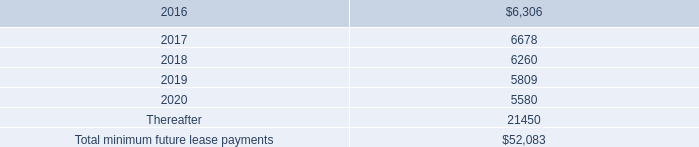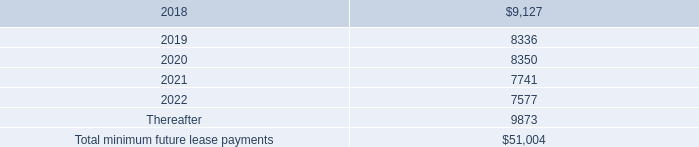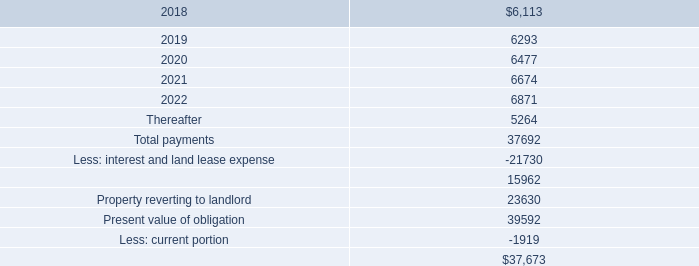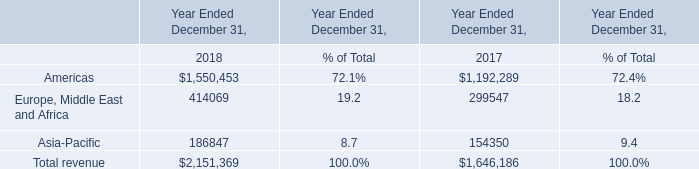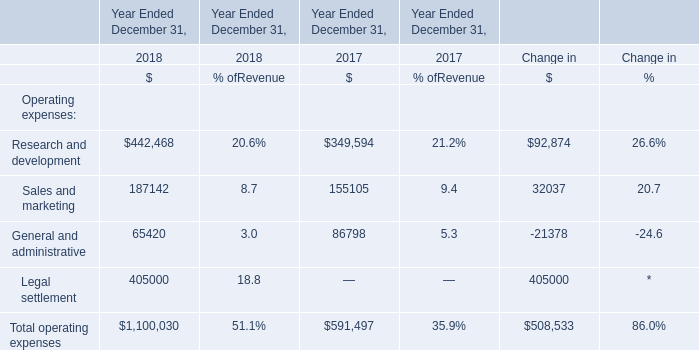What's the sum of the Operating expenses in the year where the amount of Sales and marketing is positive? (in dollars) 
Answer: 1100030. 